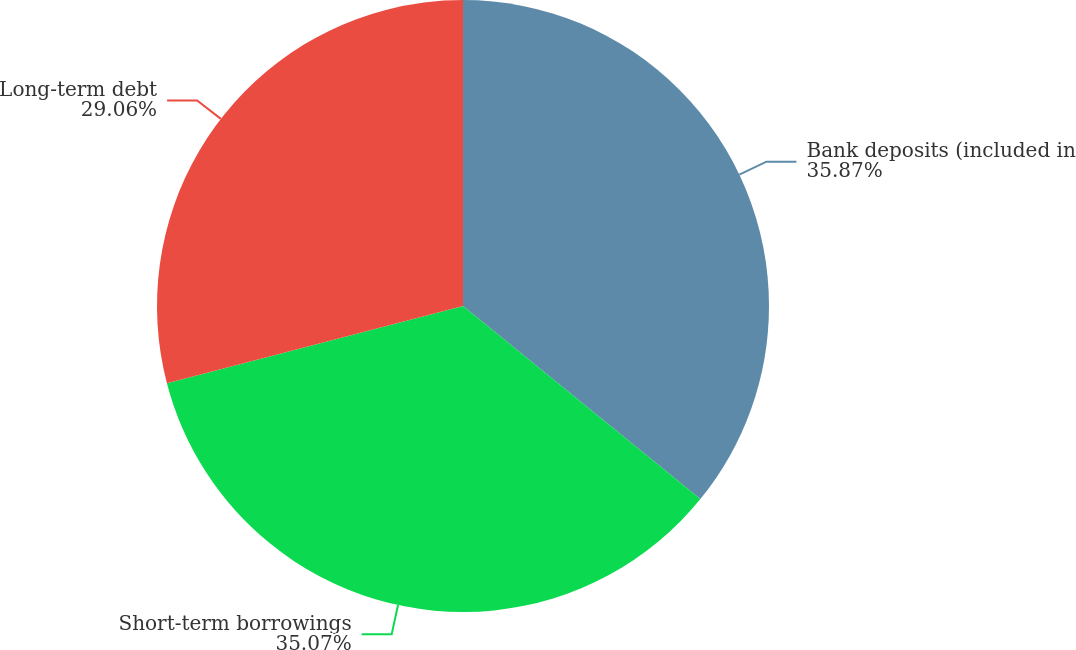<chart> <loc_0><loc_0><loc_500><loc_500><pie_chart><fcel>Bank deposits (included in<fcel>Short-term borrowings<fcel>Long-term debt<nl><fcel>35.87%<fcel>35.07%<fcel>29.06%<nl></chart> 